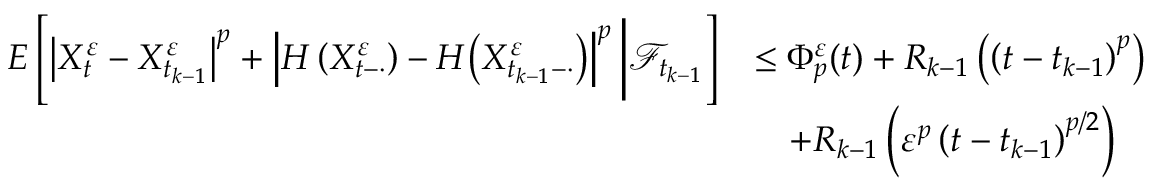<formula> <loc_0><loc_0><loc_500><loc_500>\begin{array} { r l } { E \left [ \left | X _ { t } ^ { \varepsilon } - X _ { t _ { k - 1 } } ^ { \varepsilon } \right | ^ { p } + \left | H \left ( X _ { t - \cdot } ^ { \varepsilon } \right ) - H \Big ( X _ { t _ { k - 1 } - \cdot } ^ { \varepsilon } \Big ) \right | ^ { p } \Big | \mathcal { F } _ { t _ { k - 1 } } \right ] } & { \leq \Phi _ { p } ^ { \varepsilon } ( t ) + R _ { k - 1 } \left ( \left ( t - t _ { k - 1 } \right ) ^ { p } \right ) } \\ & { \quad + R _ { k - 1 } \left ( \varepsilon ^ { p } \left ( t - t _ { k - 1 } \right ) ^ { p / 2 } \right ) } \end{array}</formula> 